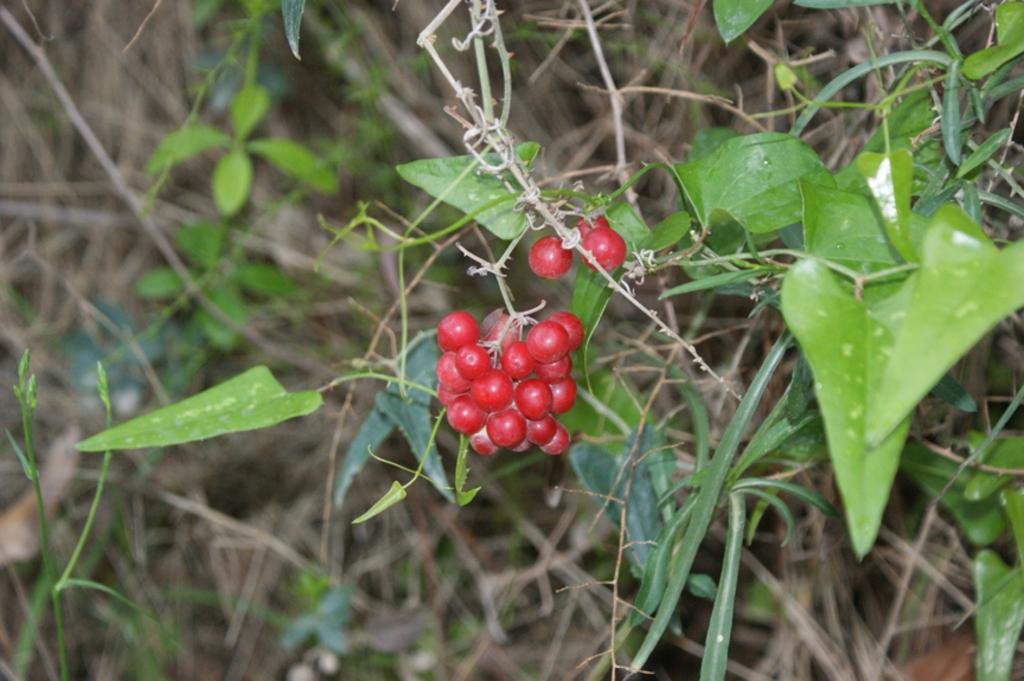What color are the leaves in the image? The leaves in the image are green. What other color can be seen in the image besides green? There are red color things in the image. How would you describe the overall clarity of the image? The image is blurry in the background. How many clocks are visible in the image? There are no clocks present in the image. What type of apples can be seen in the image? There are no apples present in the image. 